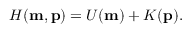Convert formula to latex. <formula><loc_0><loc_0><loc_500><loc_500>\begin{array} { r } { H ( m , p ) = U ( m ) + K ( p ) . } \end{array}</formula> 